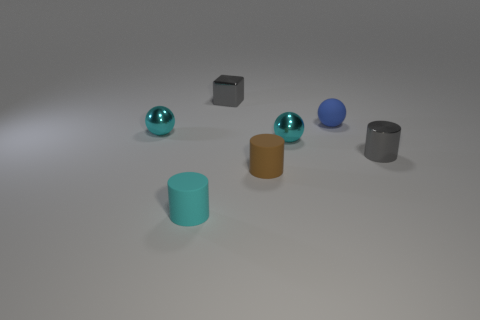Are the small cyan cylinder and the small blue ball made of the same material?
Give a very brief answer. Yes. What color is the metal thing that is the same shape as the cyan matte object?
Offer a terse response. Gray. There is a rubber cylinder that is behind the cyan rubber thing; is it the same color as the rubber ball?
Keep it short and to the point. No. What shape is the thing that is the same color as the tiny metal cylinder?
Make the answer very short. Cube. How many cyan things are made of the same material as the block?
Your response must be concise. 2. How many cyan metal balls are on the right side of the blue thing?
Your response must be concise. 0. What is the size of the blue matte thing?
Your response must be concise. Small. The matte ball that is the same size as the metal cylinder is what color?
Your response must be concise. Blue. Are there any cylinders of the same color as the tiny matte ball?
Make the answer very short. No. What is the small blue sphere made of?
Provide a short and direct response. Rubber. 